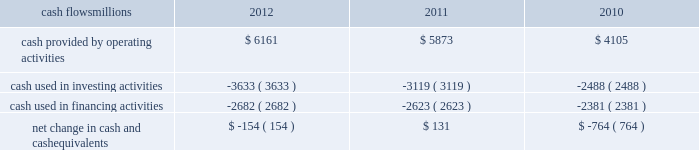At december 31 , 2012 and 2011 , we had a working capital surplus .
This reflects a strong cash position , which provides enhanced liquidity in an uncertain economic environment .
In addition , we believe we have adequate access to capital markets to meet any foreseeable cash requirements , and we have sufficient financial capacity to satisfy our current liabilities .
Cash flows millions 2012 2011 2010 .
Operating activities higher net income in 2012 increased cash provided by operating activities compared to 2011 , partially offset by lower tax benefits from bonus depreciation ( as explained below ) and payments for past wages based on national labor negotiations settled earlier this year .
Higher net income and lower cash income tax payments in 2011 increased cash provided by operating activities compared to 2010 .
The tax relief , unemployment insurance reauthorization , and job creation act of 2010 provided for 100% ( 100 % ) bonus depreciation for qualified investments made during 2011 , and 50% ( 50 % ) bonus depreciation for qualified investments made during 2012 .
As a result of the act , the company deferred a substantial portion of its 2011 income tax expense .
This deferral decreased 2011 income tax payments , thereby contributing to the positive operating cash flow .
In future years , however , additional cash will be used to pay income taxes that were previously deferred .
In addition , the adoption of a new accounting standard in january of 2010 changed the accounting treatment for our receivables securitization facility from a sale of undivided interests ( recorded as an operating activity ) to a secured borrowing ( recorded as a financing activity ) , which decreased cash provided by operating activities by $ 400 million in 2010 .
Investing activities higher capital investments in 2012 drove the increase in cash used in investing activities compared to 2011 .
Included in capital investments in 2012 was $ 75 million for the early buyout of 165 locomotives under long-term operating and capital leases during the first quarter of 2012 , which we exercised due to favorable economic terms and market conditions .
Higher capital investments partially offset by higher proceeds from asset sales in 2011 drove the increase in cash used in investing activities compared to 2010. .
What was the change in millions of cash provided by operating activities from 2010 to 2011? 
Computations: (5873 - 4105)
Answer: 1768.0. 